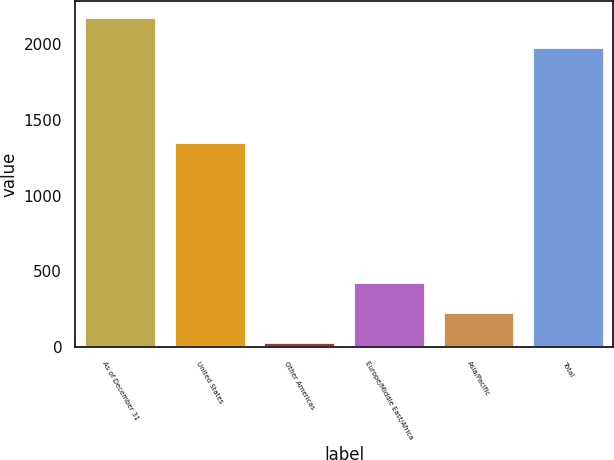Convert chart. <chart><loc_0><loc_0><loc_500><loc_500><bar_chart><fcel>As of December 31<fcel>United States<fcel>Other Americas<fcel>Europe/Middle East/Africa<fcel>Asia/Pacific<fcel>Total<nl><fcel>2176.1<fcel>1353<fcel>36<fcel>430.2<fcel>233.1<fcel>1979<nl></chart> 